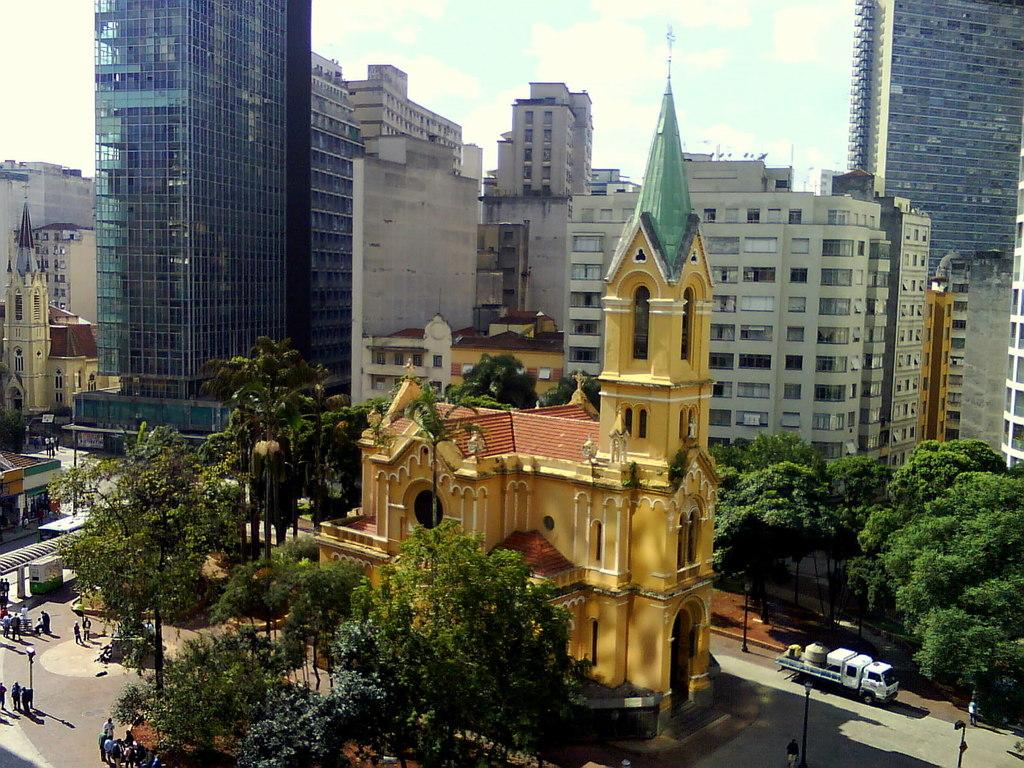What type of structures can be seen in the image? There are buildings in the image. What other natural elements are present in the image? There are trees in the image. What mode of transportation can be seen on the road at the bottom of the image? Vehicles are visible on the road at the bottom of the image. Are there any living beings present in the image? Yes, people are visible in the image. What are the poles used for in the image? The poles might be used for various purposes, such as streetlights or signage. What can be seen in the background of the image? The sky is visible in the background of the image. What type of shirt is the force wearing in the image? There is no force or shirt present in the image. Is the quill used for writing in the image? There is no quill present in the image. 